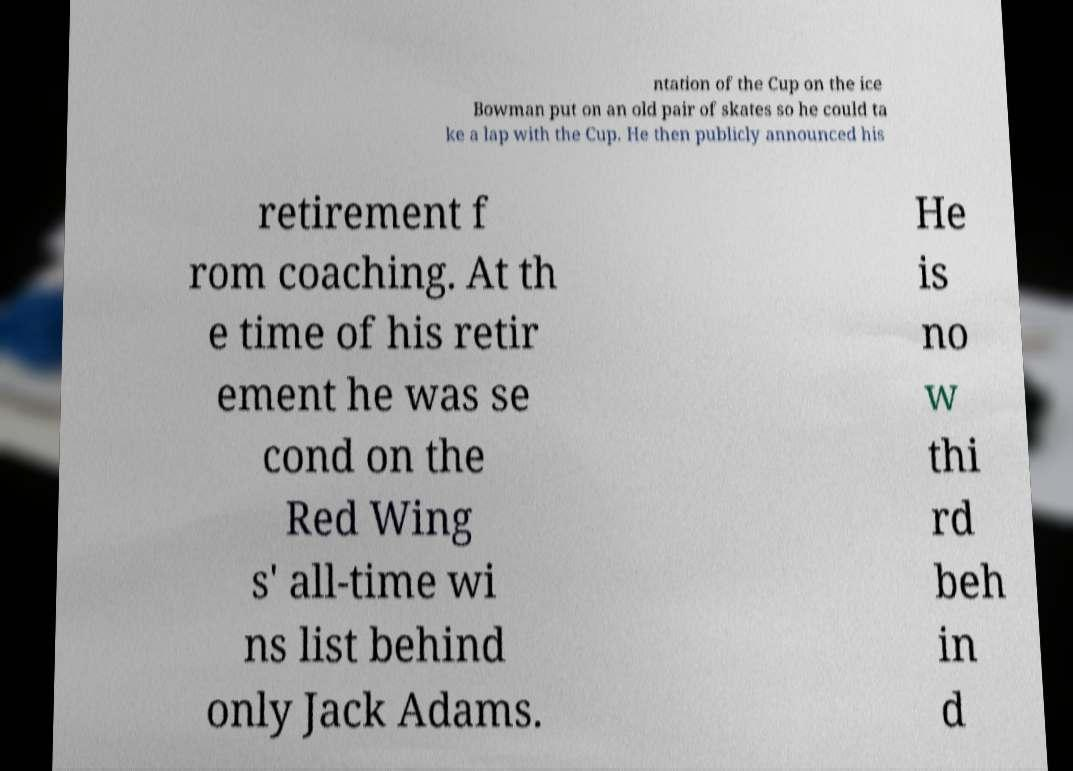Could you assist in decoding the text presented in this image and type it out clearly? ntation of the Cup on the ice Bowman put on an old pair of skates so he could ta ke a lap with the Cup. He then publicly announced his retirement f rom coaching. At th e time of his retir ement he was se cond on the Red Wing s' all-time wi ns list behind only Jack Adams. He is no w thi rd beh in d 